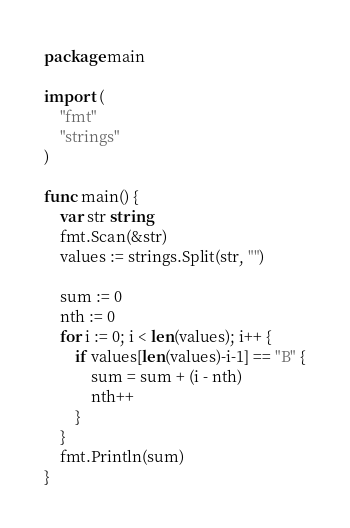<code> <loc_0><loc_0><loc_500><loc_500><_Go_>package main

import (
	"fmt"
	"strings"
)

func main() {
	var str string
	fmt.Scan(&str)
	values := strings.Split(str, "")

	sum := 0
	nth := 0
	for i := 0; i < len(values); i++ {
		if values[len(values)-i-1] == "B" {
			sum = sum + (i - nth)
			nth++
		}
	}
	fmt.Println(sum)
}
</code> 